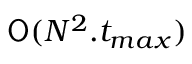Convert formula to latex. <formula><loc_0><loc_0><loc_500><loc_500>O ( N ^ { 2 } . t _ { \max } )</formula> 